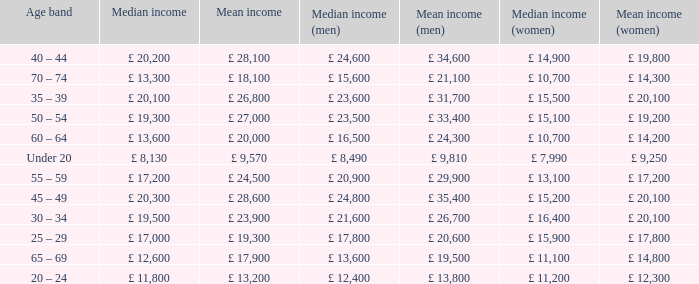Name the median income for age band being under 20 £ 8,130. 